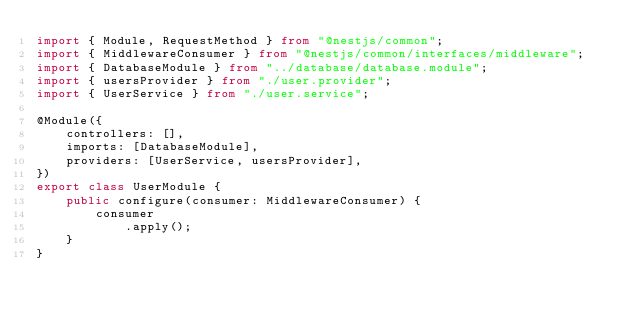<code> <loc_0><loc_0><loc_500><loc_500><_TypeScript_>import { Module, RequestMethod } from "@nestjs/common";
import { MiddlewareConsumer } from "@nestjs/common/interfaces/middleware";
import { DatabaseModule } from "../database/database.module";
import { usersProvider } from "./user.provider";
import { UserService } from "./user.service";

@Module({
    controllers: [],
    imports: [DatabaseModule],
    providers: [UserService, usersProvider],
})
export class UserModule {
    public configure(consumer: MiddlewareConsumer) {
        consumer
            .apply();
    }
}
</code> 